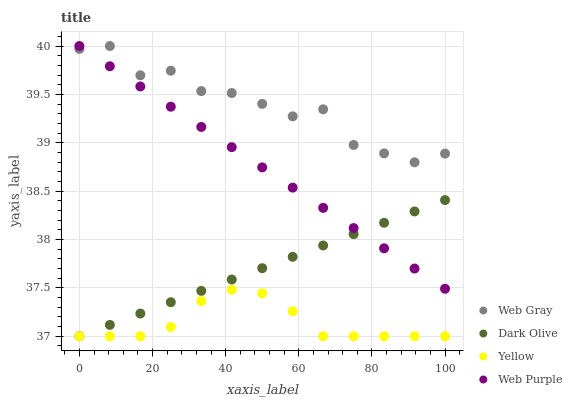Does Yellow have the minimum area under the curve?
Answer yes or no. Yes. Does Web Gray have the maximum area under the curve?
Answer yes or no. Yes. Does Web Purple have the minimum area under the curve?
Answer yes or no. No. Does Web Purple have the maximum area under the curve?
Answer yes or no. No. Is Dark Olive the smoothest?
Answer yes or no. Yes. Is Web Gray the roughest?
Answer yes or no. Yes. Is Web Purple the smoothest?
Answer yes or no. No. Is Web Purple the roughest?
Answer yes or no. No. Does Dark Olive have the lowest value?
Answer yes or no. Yes. Does Web Purple have the lowest value?
Answer yes or no. No. Does Web Gray have the highest value?
Answer yes or no. Yes. Does Yellow have the highest value?
Answer yes or no. No. Is Dark Olive less than Web Gray?
Answer yes or no. Yes. Is Web Gray greater than Yellow?
Answer yes or no. Yes. Does Web Gray intersect Web Purple?
Answer yes or no. Yes. Is Web Gray less than Web Purple?
Answer yes or no. No. Is Web Gray greater than Web Purple?
Answer yes or no. No. Does Dark Olive intersect Web Gray?
Answer yes or no. No. 